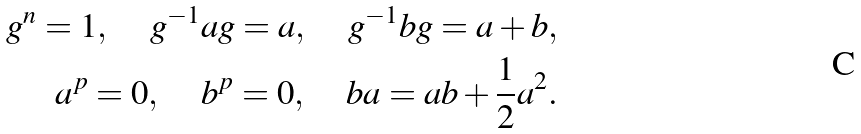<formula> <loc_0><loc_0><loc_500><loc_500>g ^ { n } = 1 , \quad \, g ^ { - 1 } a g = a , \quad \, g ^ { - 1 } b g = a + b , \\ a ^ { p } = 0 , \quad \, b ^ { p } = 0 , \quad \, b a = a b + \frac { 1 } { 2 } a ^ { 2 } .</formula> 